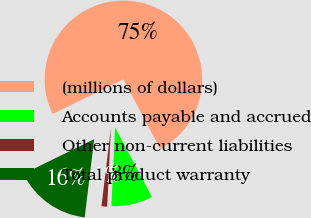Convert chart. <chart><loc_0><loc_0><loc_500><loc_500><pie_chart><fcel>(millions of dollars)<fcel>Accounts payable and accrued<fcel>Other non-current liabilities<fcel>Total product warranty<nl><fcel>74.51%<fcel>8.5%<fcel>1.16%<fcel>15.83%<nl></chart> 